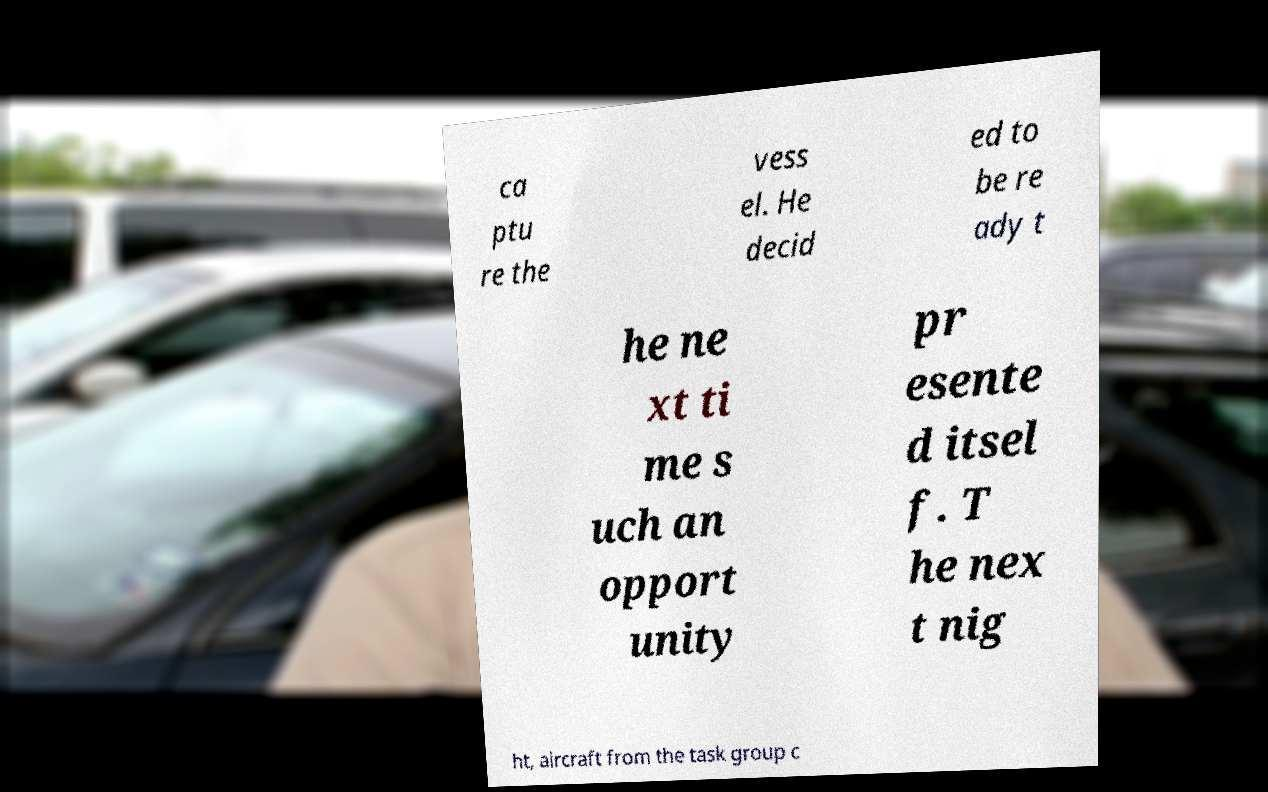Please identify and transcribe the text found in this image. ca ptu re the vess el. He decid ed to be re ady t he ne xt ti me s uch an opport unity pr esente d itsel f. T he nex t nig ht, aircraft from the task group c 